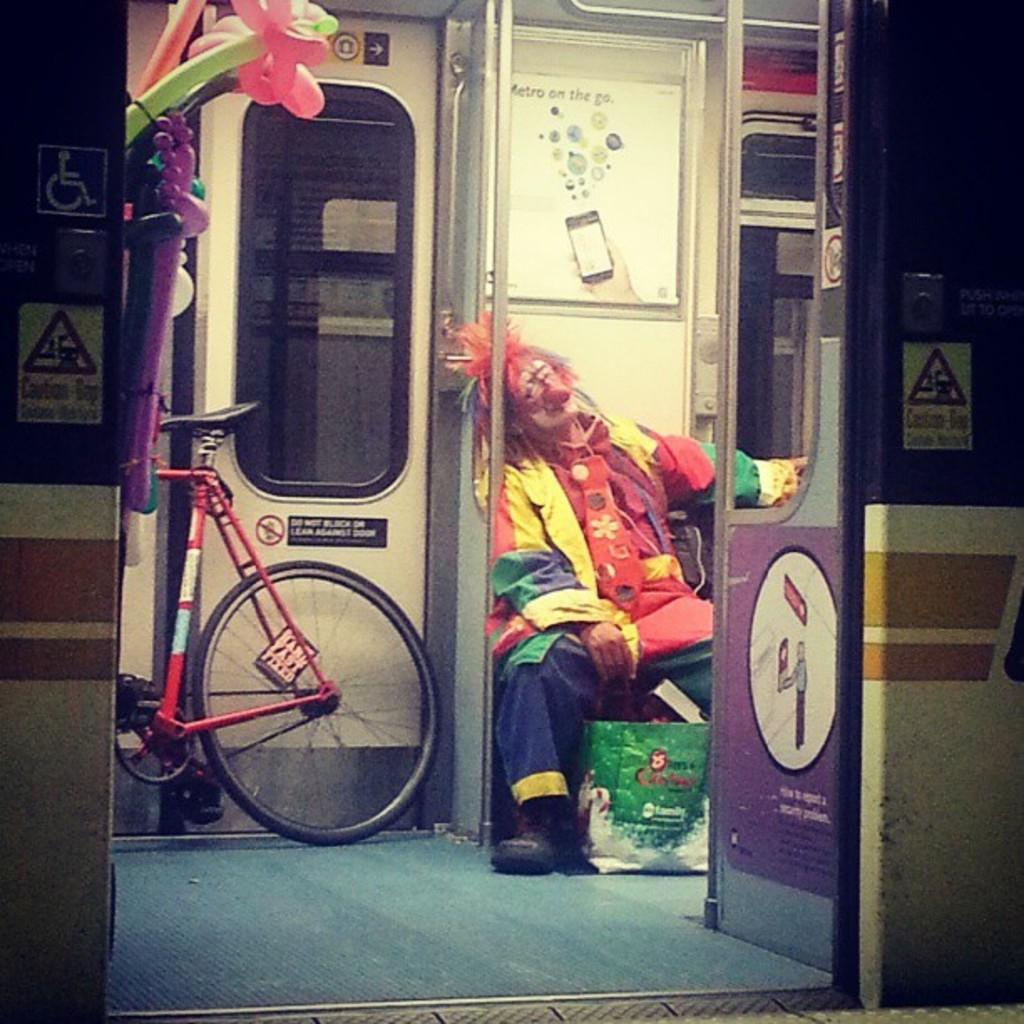What is the person in the image doing? There is a person sitting in the train. What is in front of the person? There is a bag in front of the person. What can be seen on the left side of the image? There is a bicycle and balloons on the left side of the image. What type of lawyer is leading the silver balloons in the image? There is no lawyer or silver balloons present in the image. 